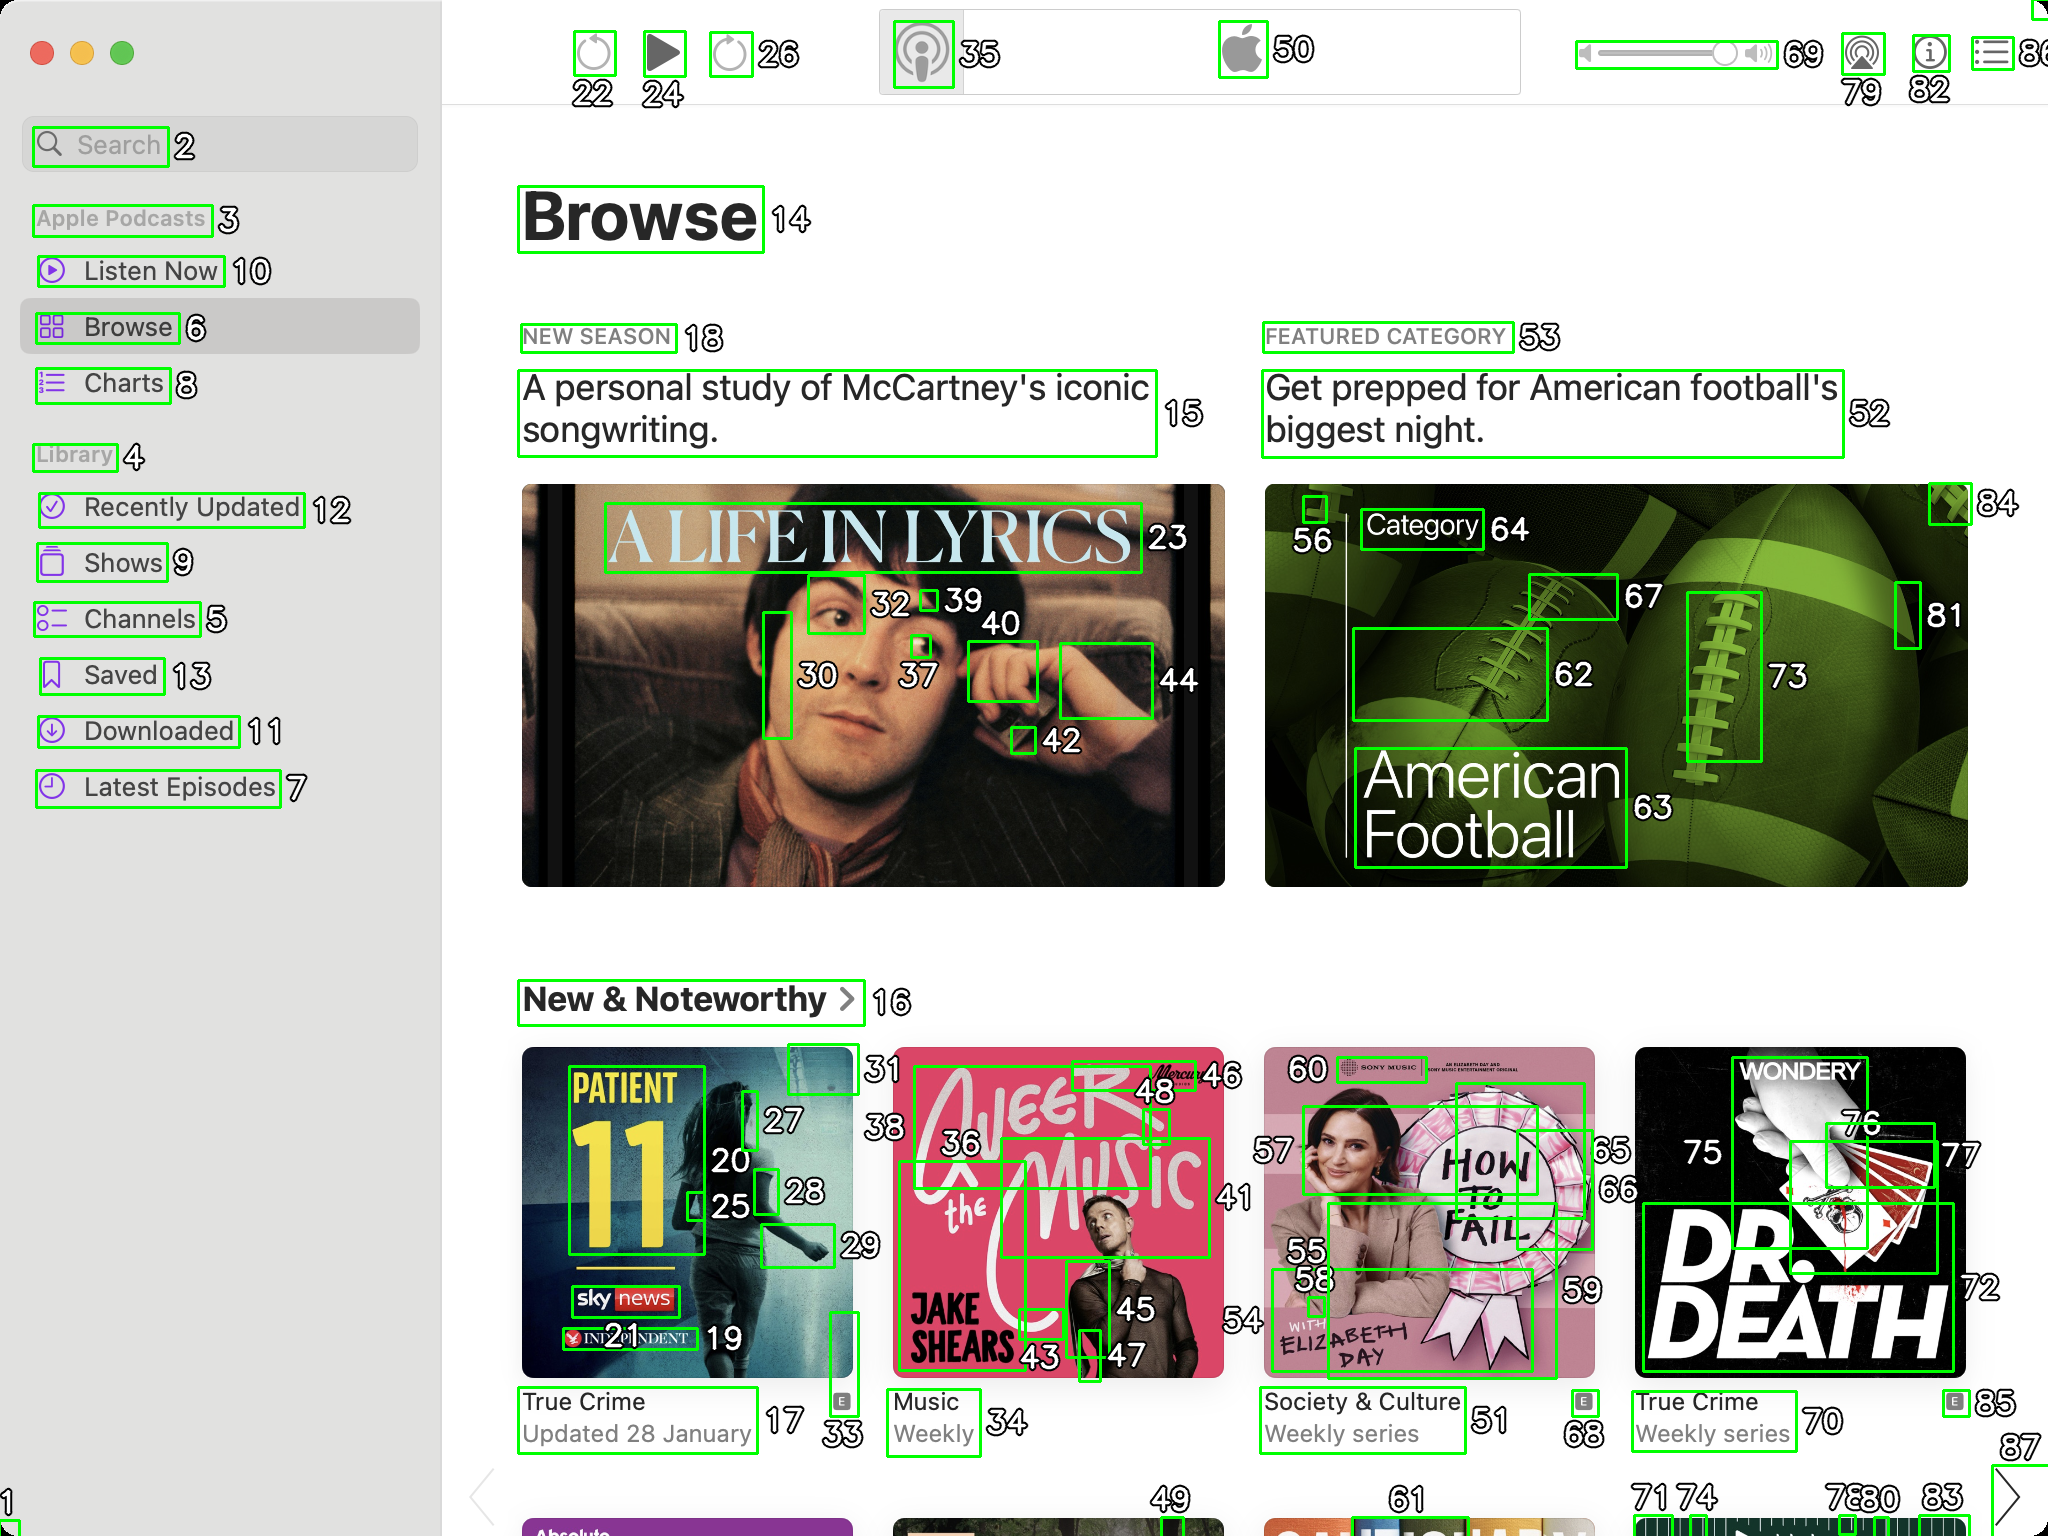You are an AI designed for image processing and segmentation analysis, particularly skilled in merging segmented regions of an image to improve accuracy and readability.

**Task Description:**
Your task is to address a user's concern with a UI screenshot of the Apple Podcasts application on MacOS. The screenshot contains multiple green boxes, each representing a UI element, with a unique white number outlined in black ranging from 1 to 88. Due to segmentation issues, some boxes that belong to the same image are divided unnaturally.

**Objective:**
Merge these segmented areas that correspond to a single UI element to create a coherent representation. The final output should be in JSON format, where each key-value pair represents the merged areas.

**Example JSON Output:**
If boxes with numbers 1, 2, and 3 should belong to the same UI element, the JSON output should be:

```json
{
    "Image A Life In Lyrics": [1, 2, 3]
}
```

**Instructions:**

- **Identify Segmented Regions:** Analyze the screenshot to identify which green boxes belong to the same UI element.
- **Merge Regions:** Group the numbers of these boxes together to represent a single UI element.
- **Output Format:** Produce the output in JSON format, with each key representing a UI element and each value being a list of the numbers of the merged boxes. Don't include in the result UI elements that consist of one box.

**Primary Objective:**
Ensure the accuracy of the merged regions based on the user's supplied image information, maintaining the integrity and structure of the UI elements in the Apple Podcasts application on MacOS. Based on the analysis of the screenshot, I've identified and merged segmented regions that correspond to the same UI elements. Below is the JSON output representing the merged areas:

```json
{
    "Search": [1, 2],
    "Library": [4, 12],
    "Browse": [14],
    "A Life In Lyrics": [29, 30, 37, 40, 42, 44],
    "Get prepped for American football's biggest night": [52, 53, 56, 62, 63, 64, 67, 73, 81, 84],
    "Patient 11": [17, 20, 25, 27, 28, 33],
    "Alger Music": [36, 43, 45, 46, 48],
    "How to Fail": [55, 58, 59],
    "Dr. Death": [72, 75, 76, 77, 78, 80, 85]
}
```

This JSON structure merges the segmented areas of the UI elements based on their respective boxes, ensuring a coherent representation of each element. Each key corresponds to the identifiable UI element, and the value is a list of numbers representing the merged boxes. 